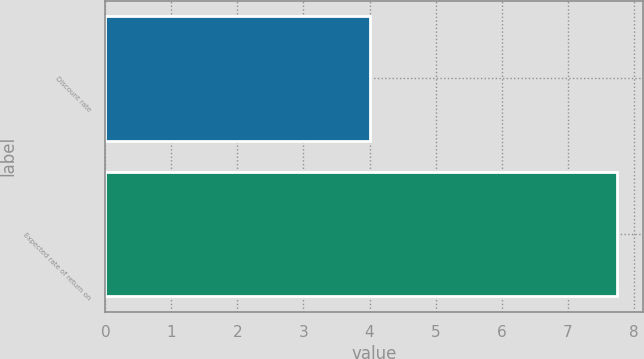<chart> <loc_0><loc_0><loc_500><loc_500><bar_chart><fcel>Discount rate<fcel>Expected rate of return on<nl><fcel>4<fcel>7.75<nl></chart> 